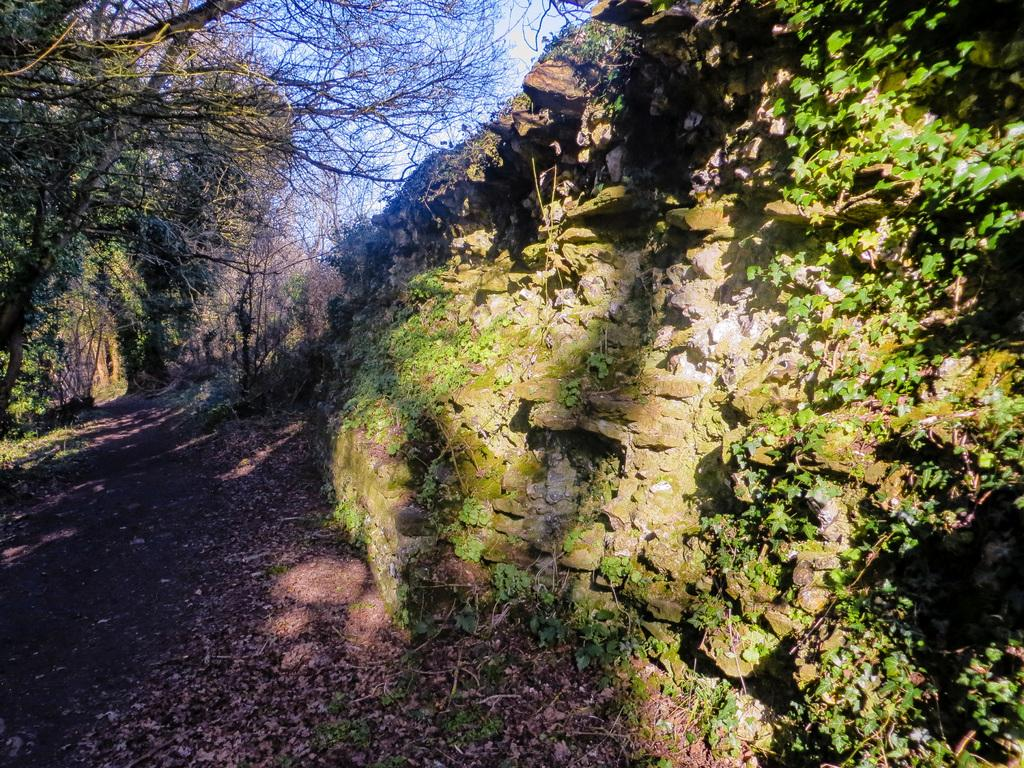What type of landscape is depicted in the image? The image features hills. What type of vegetation can be seen growing on the hills? Creepers are present in the image. What is scattered on the ground in the image? Shredded leaves are visible in the image. What is the ground made of in the image? The ground is visible in the image. What other natural elements can be seen in the image? There are trees in the image. What is visible above the landscape in the image? The sky is visible in the image. What type of pies are being sold at the park in the image? There is no park or pies present in the image; it features a landscape with hills, creepers, shredded leaves, trees, and the sky. 